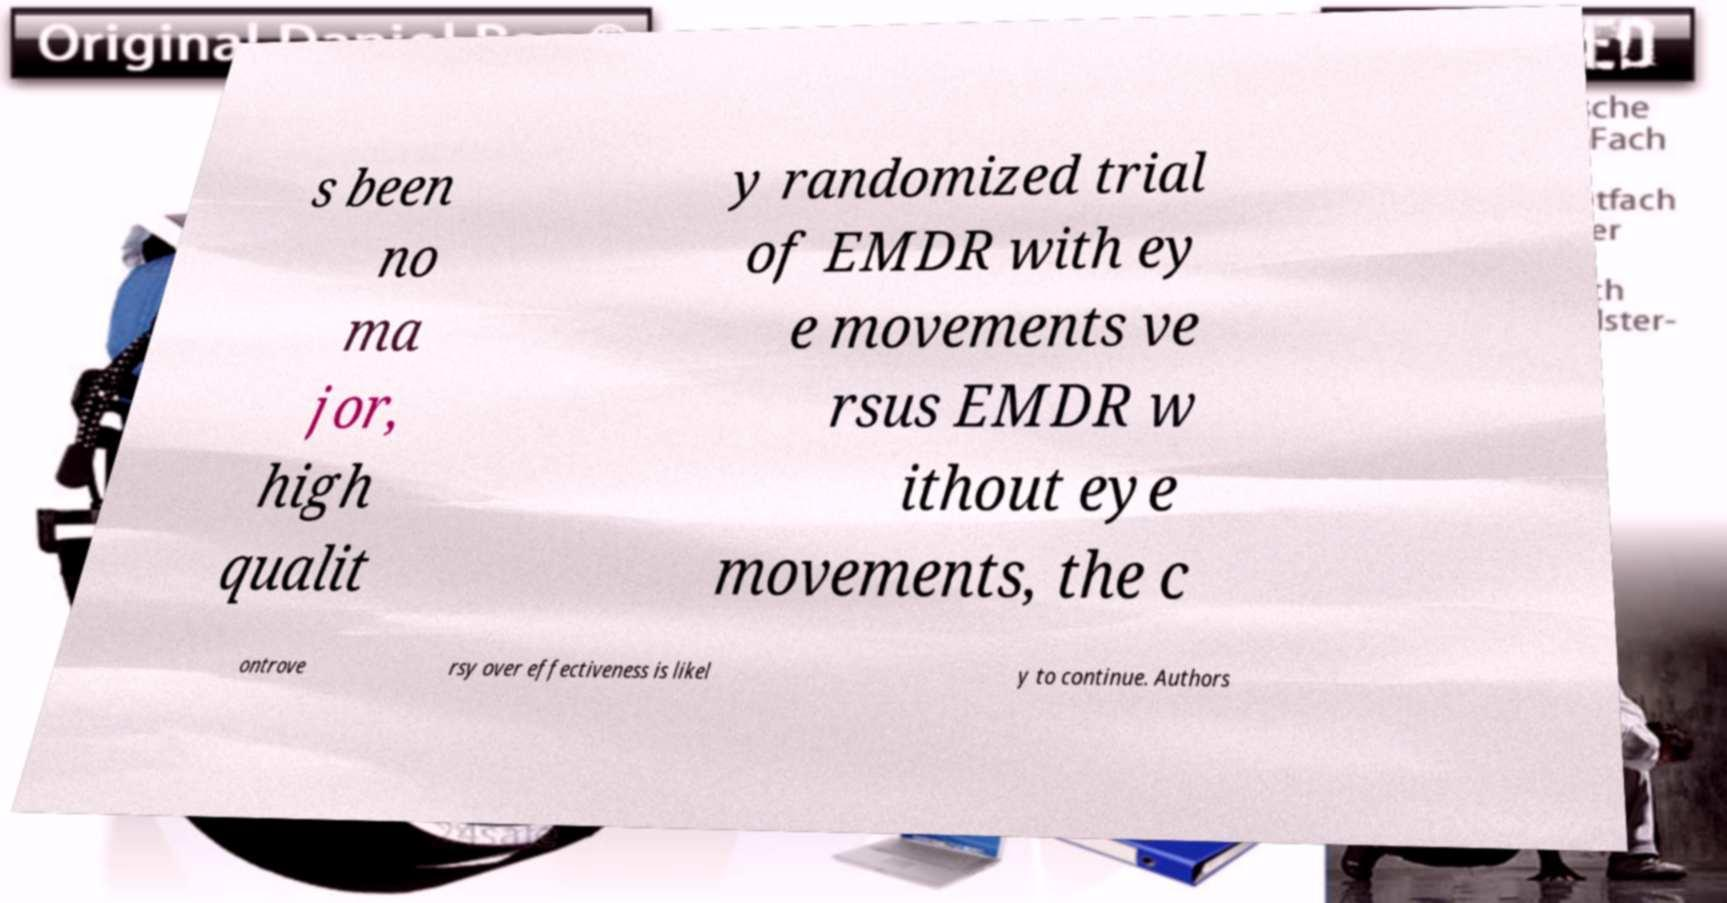What messages or text are displayed in this image? I need them in a readable, typed format. s been no ma jor, high qualit y randomized trial of EMDR with ey e movements ve rsus EMDR w ithout eye movements, the c ontrove rsy over effectiveness is likel y to continue. Authors 